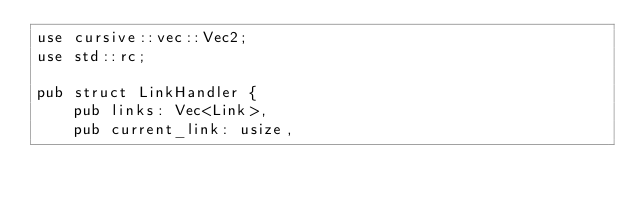Convert code to text. <code><loc_0><loc_0><loc_500><loc_500><_Rust_>use cursive::vec::Vec2;
use std::rc;

pub struct LinkHandler {
    pub links: Vec<Link>,
    pub current_link: usize,
</code> 